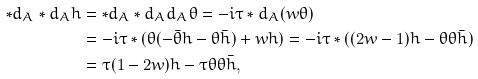Convert formula to latex. <formula><loc_0><loc_0><loc_500><loc_500>\ast d _ { A } \ast d _ { A } h & = \ast d _ { A } \ast d _ { A } d _ { A } \theta = - i \tau \ast d _ { A } ( w \theta ) \\ & = - i \tau \ast ( \theta ( - \bar { \theta } h - \theta \bar { h } ) + w h ) = - i \tau \ast ( ( 2 w - 1 ) h - \theta \theta \bar { h } ) \\ & = \tau ( 1 - 2 w ) h - \tau \theta \theta \bar { h } ,</formula> 